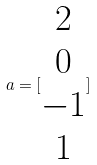<formula> <loc_0><loc_0><loc_500><loc_500>a = [ \begin{matrix} 2 \\ 0 \\ - 1 \\ 1 \end{matrix} ]</formula> 